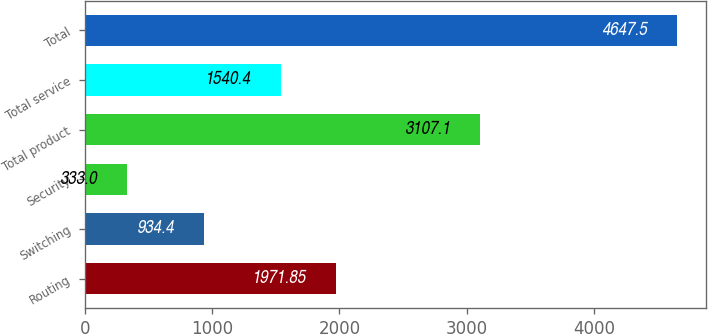Convert chart. <chart><loc_0><loc_0><loc_500><loc_500><bar_chart><fcel>Routing<fcel>Switching<fcel>Security<fcel>Total product<fcel>Total service<fcel>Total<nl><fcel>1971.85<fcel>934.4<fcel>333<fcel>3107.1<fcel>1540.4<fcel>4647.5<nl></chart> 